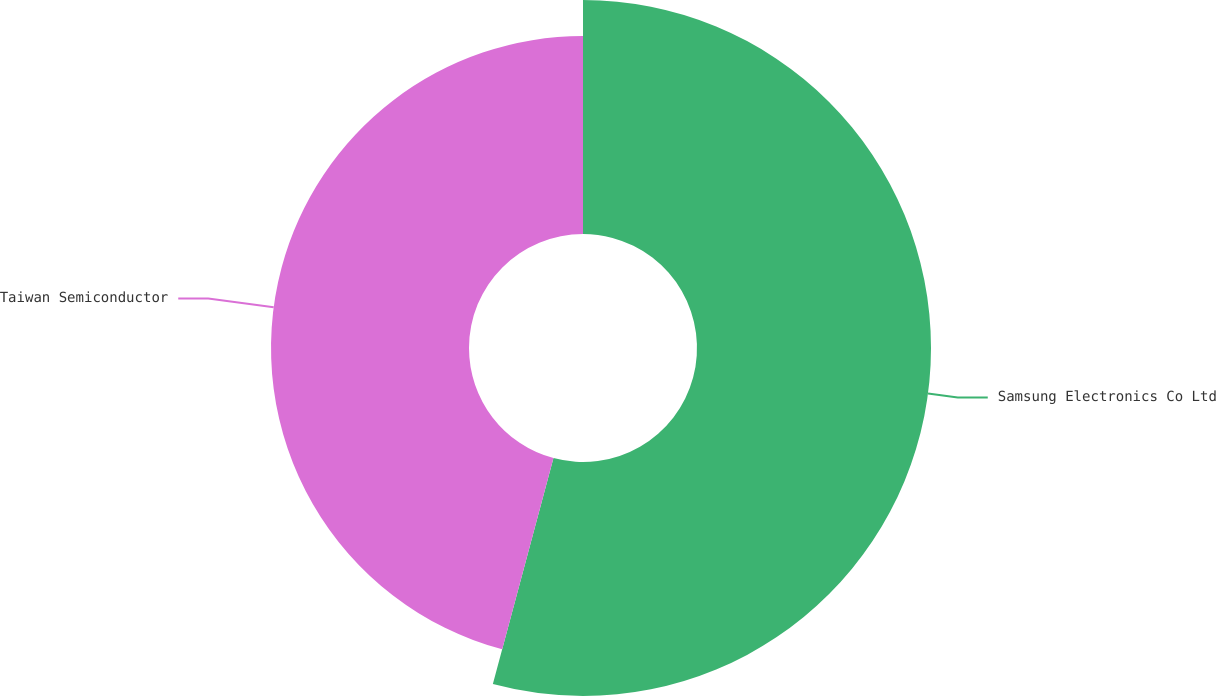<chart> <loc_0><loc_0><loc_500><loc_500><pie_chart><fcel>Samsung Electronics Co Ltd<fcel>Taiwan Semiconductor<nl><fcel>54.17%<fcel>45.83%<nl></chart> 